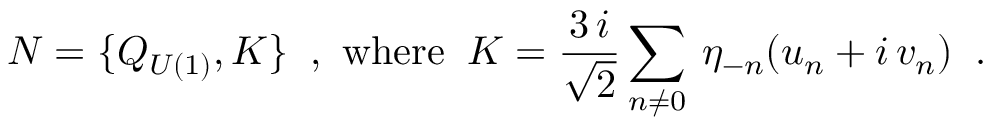Convert formula to latex. <formula><loc_0><loc_0><loc_500><loc_500>N = \{ Q _ { U ( 1 ) } , K \} \, , w h e r e \, K = \frac { 3 \, i } { \sqrt { 2 } } \sum _ { n \neq 0 } \, \eta _ { - n } ( u _ { n } + i \, v _ { n } ) \, .</formula> 